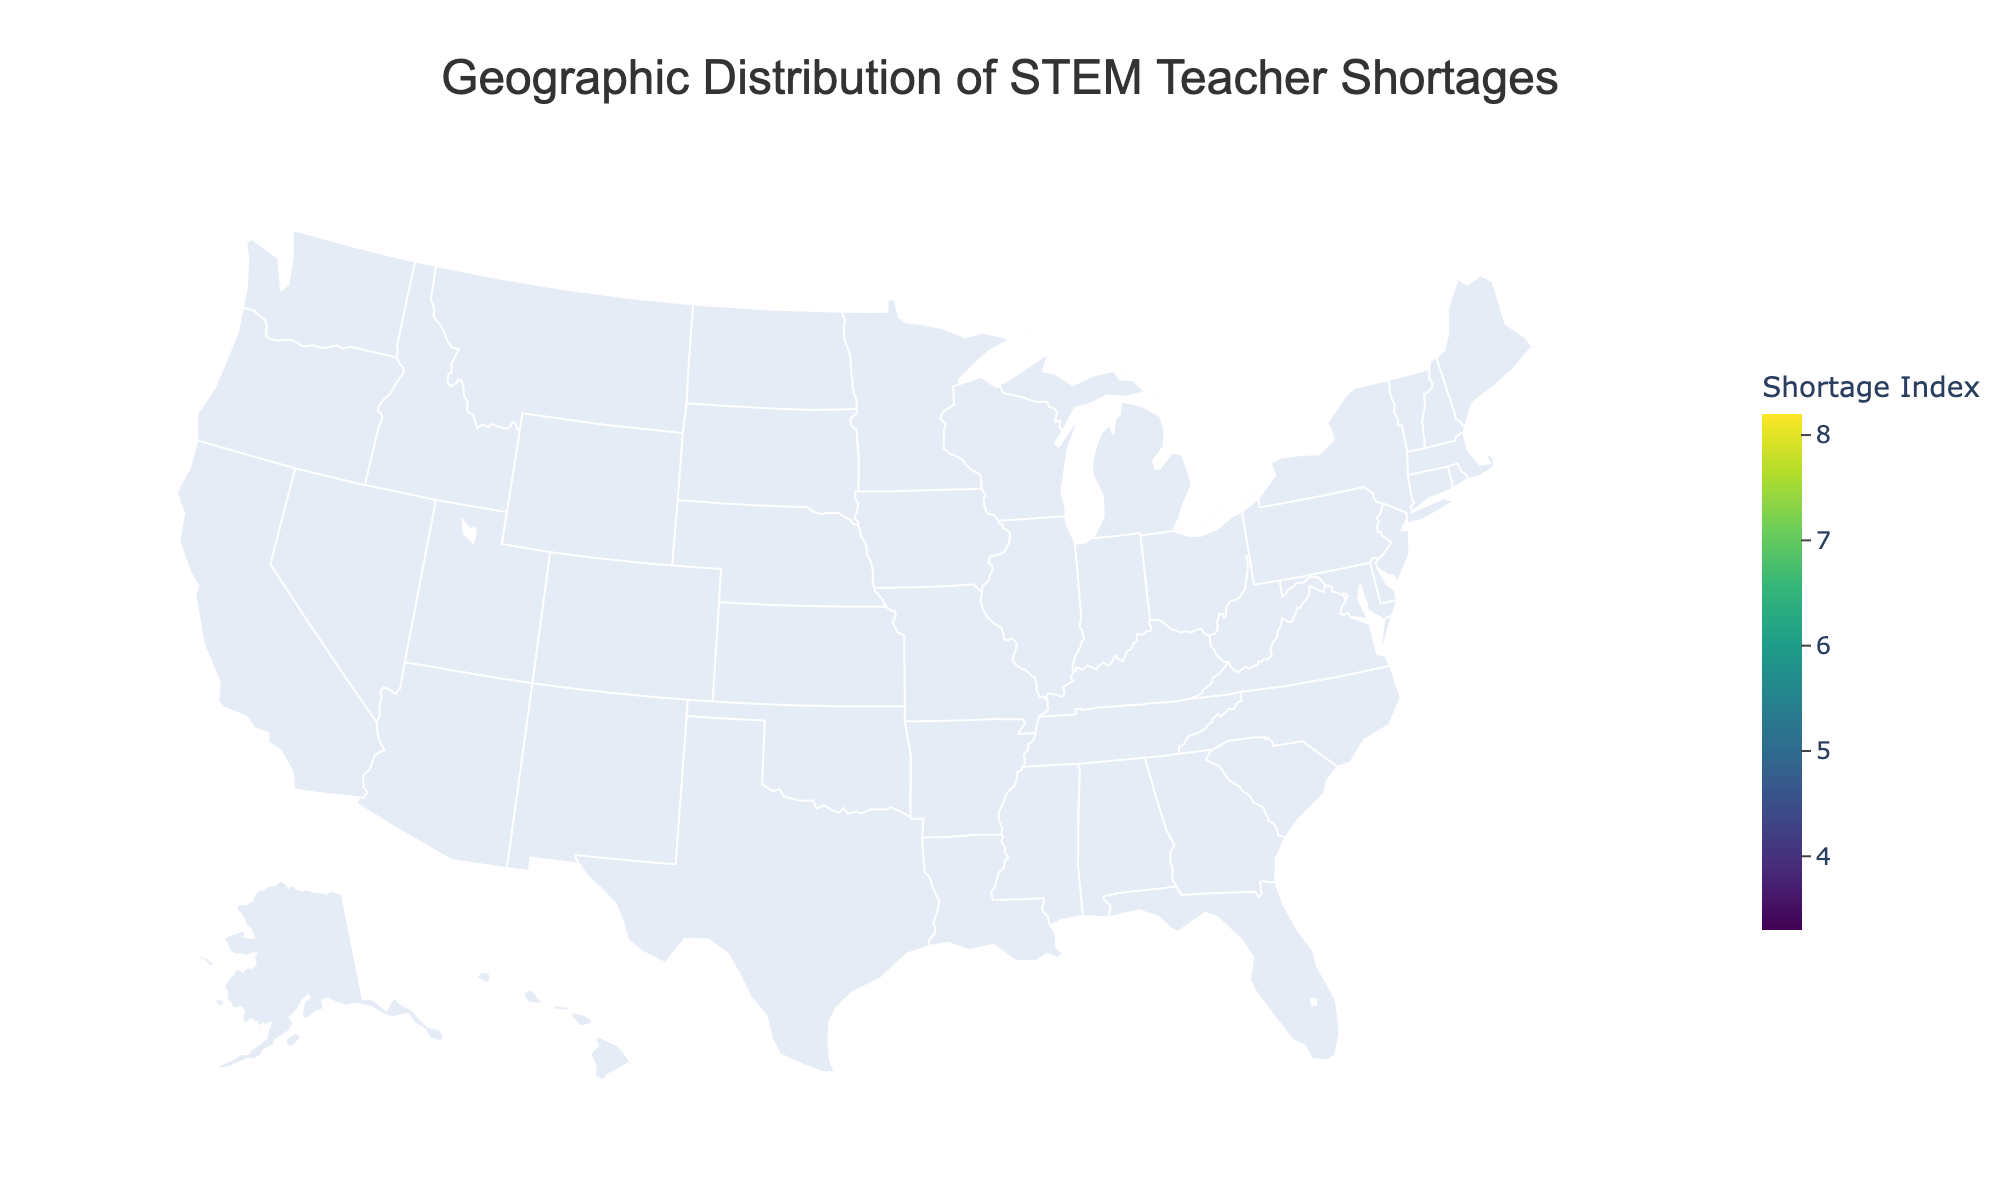What's the title of the plot? The title is usually located at the top of the plot. It reads "Geographic Distribution of STEM Teacher Shortages".
Answer: Geographic Distribution of STEM Teacher Shortages Which state has the highest STEM Teacher Shortage Index? From the color gradients on the map, darker shades indicate higher shortage indices. The state with the deepest color is California with a STEM Teacher Shortage Index of 8.2.
Answer: California How does the average teacher salary in Texas compare to Florida? By hovering over Texas and Florida on the map, we see that Texas has an average teacher salary of $57,641 while Florida's is $49,102. Texas has a higher average teacher salary than Florida.
Answer: Texas has a higher average salary What is the average STEM Teacher Shortage Index of the states with an average teacher salary above $70,000? Only California, New York, Massachusetts, and Washington have average salaries above $70,000. Their indices are 8.2, 6.8, 4.5, and 4.9 respectively. The average is calculated as (8.2 + 6.8 + 4.5 + 4.9) / 4 = 6.1.
Answer: 6.1 Which state among Illinois, Ohio, and Pennsylvania has the highest STEM Teacher Shortage Index? Comparing the indices, Illinois has 6.5, Ohio has 6.2, and Pennsylvania has 5.9. Illinois has the highest value among the three.
Answer: Illinois Which state has the lowest STEM Teacher Shortage Index? By observing the color gradients and hovering over each state, Colorado has the lightest shade with a shortage index of 3.3.
Answer: Colorado Is there a relationship between the average teacher salary and the STEM Teacher Shortage Index? By looking at the map and noting states with varying salaries and shortage indices, it appears there's no clear direct correlation. States like New York have high salaries but moderate shortage indices, while California has both high salary and high shortage index.
Answer: No clear correlation How many states have a STEM Teacher Shortage Index above 5.0? The states with indices above 5.0 are California, Texas, Florida, New York, Illinois, Ohio, Pennsylvania, and Michigan. Counting these, there are 8.
Answer: 8 Which state has a lower STEM Teacher Shortage Index: Massachusetts or New Jersey? Hovering over Massachusetts and New Jersey shows indices of 4.5 and 4.3 respectively. New Jersey has the lower index.
Answer: New Jersey Which states with an average teacher salary below $60,000 have a STEM Teacher Shortage Index above 6.0? Texas ($57,641, 7.9), Florida ($49,102, 7.5), and Ohio ($59,168, 6.2) all fit the criteria.
Answer: Texas, Florida, Ohio 